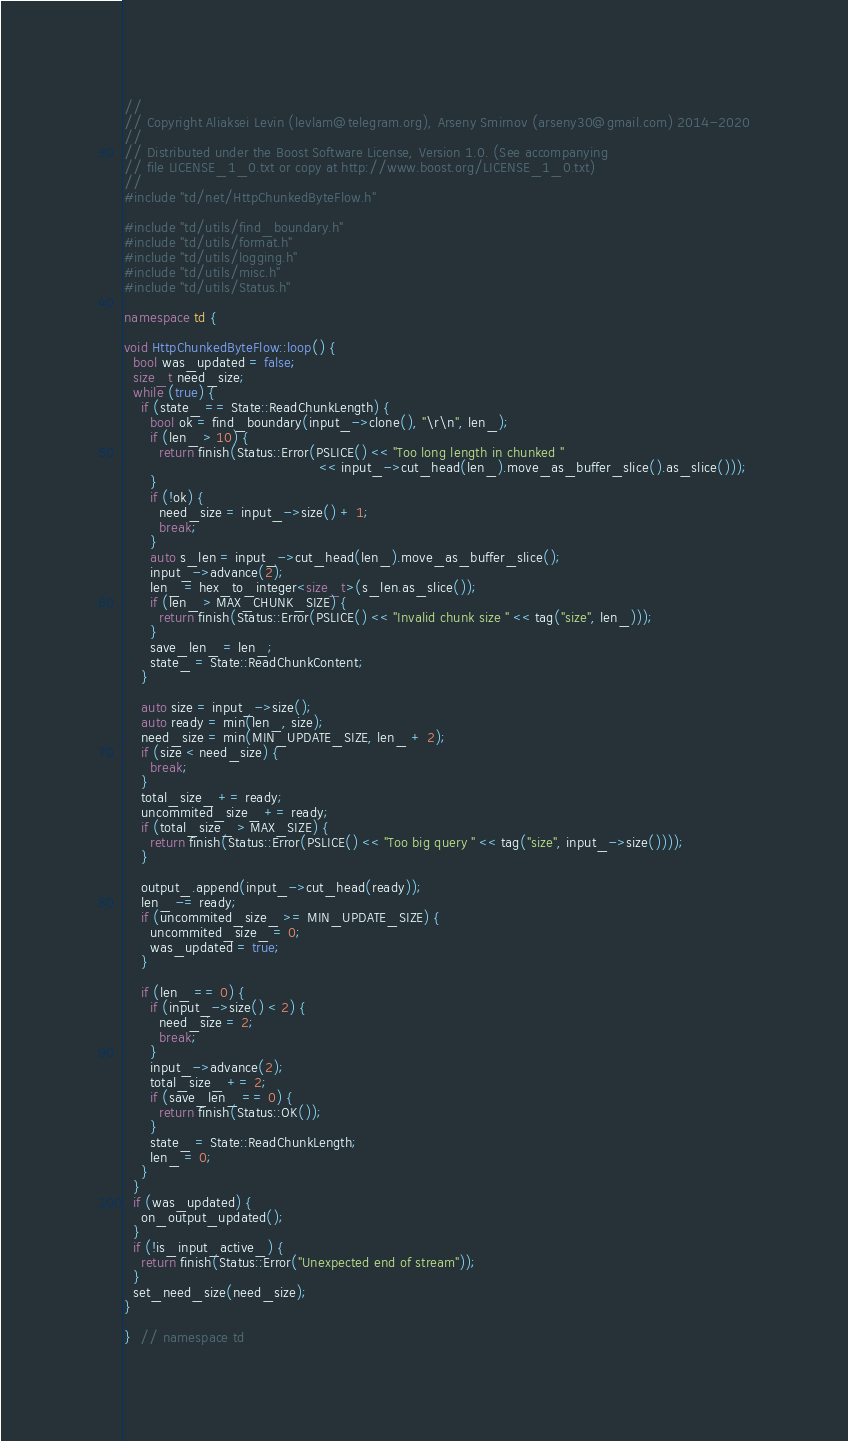<code> <loc_0><loc_0><loc_500><loc_500><_C++_>//
// Copyright Aliaksei Levin (levlam@telegram.org), Arseny Smirnov (arseny30@gmail.com) 2014-2020
//
// Distributed under the Boost Software License, Version 1.0. (See accompanying
// file LICENSE_1_0.txt or copy at http://www.boost.org/LICENSE_1_0.txt)
//
#include "td/net/HttpChunkedByteFlow.h"

#include "td/utils/find_boundary.h"
#include "td/utils/format.h"
#include "td/utils/logging.h"
#include "td/utils/misc.h"
#include "td/utils/Status.h"

namespace td {

void HttpChunkedByteFlow::loop() {
  bool was_updated = false;
  size_t need_size;
  while (true) {
    if (state_ == State::ReadChunkLength) {
      bool ok = find_boundary(input_->clone(), "\r\n", len_);
      if (len_ > 10) {
        return finish(Status::Error(PSLICE() << "Too long length in chunked "
                                             << input_->cut_head(len_).move_as_buffer_slice().as_slice()));
      }
      if (!ok) {
        need_size = input_->size() + 1;
        break;
      }
      auto s_len = input_->cut_head(len_).move_as_buffer_slice();
      input_->advance(2);
      len_ = hex_to_integer<size_t>(s_len.as_slice());
      if (len_ > MAX_CHUNK_SIZE) {
        return finish(Status::Error(PSLICE() << "Invalid chunk size " << tag("size", len_)));
      }
      save_len_ = len_;
      state_ = State::ReadChunkContent;
    }

    auto size = input_->size();
    auto ready = min(len_, size);
    need_size = min(MIN_UPDATE_SIZE, len_ + 2);
    if (size < need_size) {
      break;
    }
    total_size_ += ready;
    uncommited_size_ += ready;
    if (total_size_ > MAX_SIZE) {
      return finish(Status::Error(PSLICE() << "Too big query " << tag("size", input_->size())));
    }

    output_.append(input_->cut_head(ready));
    len_ -= ready;
    if (uncommited_size_ >= MIN_UPDATE_SIZE) {
      uncommited_size_ = 0;
      was_updated = true;
    }

    if (len_ == 0) {
      if (input_->size() < 2) {
        need_size = 2;
        break;
      }
      input_->advance(2);
      total_size_ += 2;
      if (save_len_ == 0) {
        return finish(Status::OK());
      }
      state_ = State::ReadChunkLength;
      len_ = 0;
    }
  }
  if (was_updated) {
    on_output_updated();
  }
  if (!is_input_active_) {
    return finish(Status::Error("Unexpected end of stream"));
  }
  set_need_size(need_size);
}

}  // namespace td
</code> 